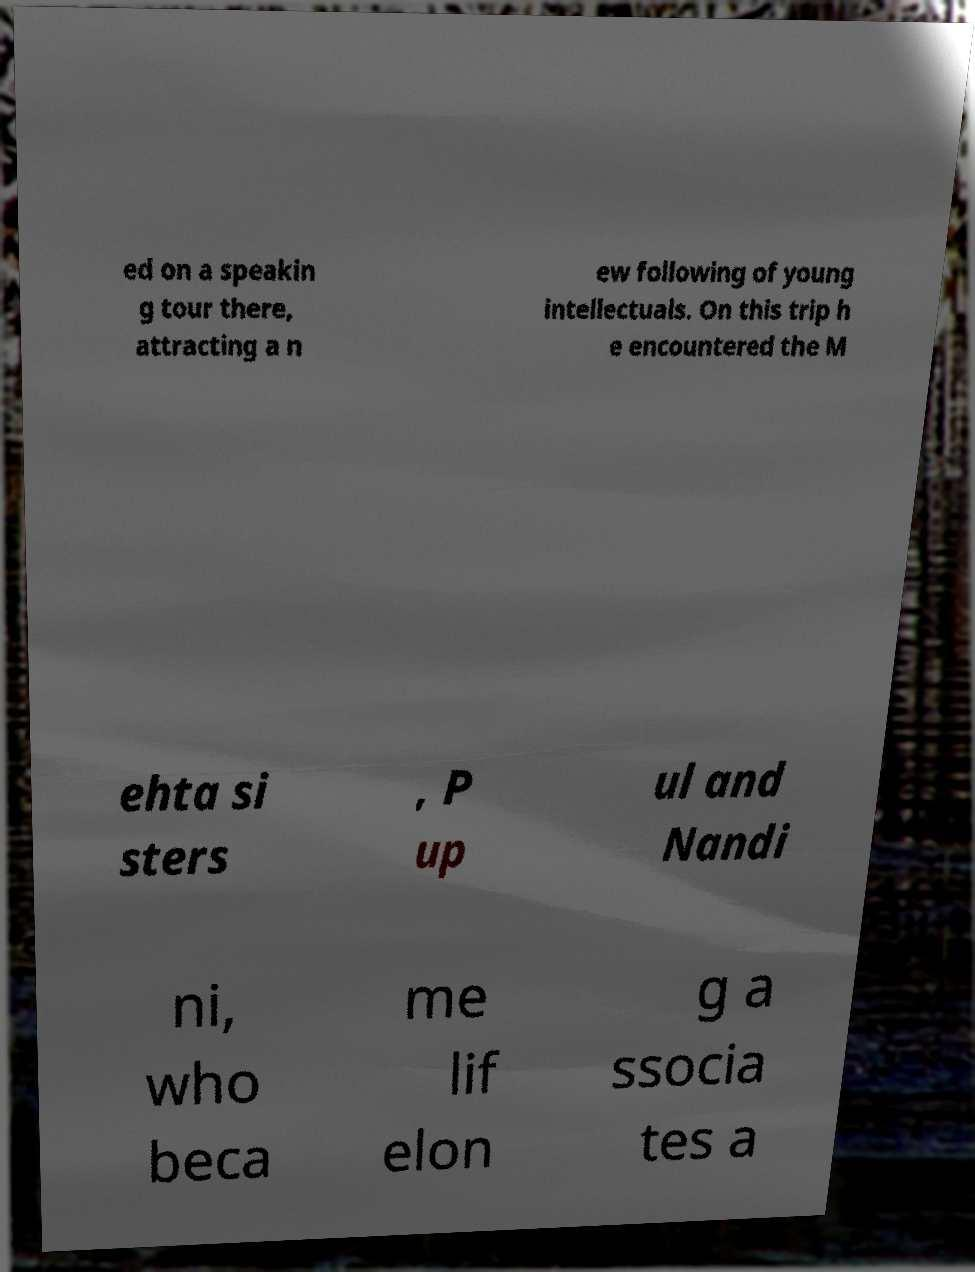I need the written content from this picture converted into text. Can you do that? ed on a speakin g tour there, attracting a n ew following of young intellectuals. On this trip h e encountered the M ehta si sters , P up ul and Nandi ni, who beca me lif elon g a ssocia tes a 